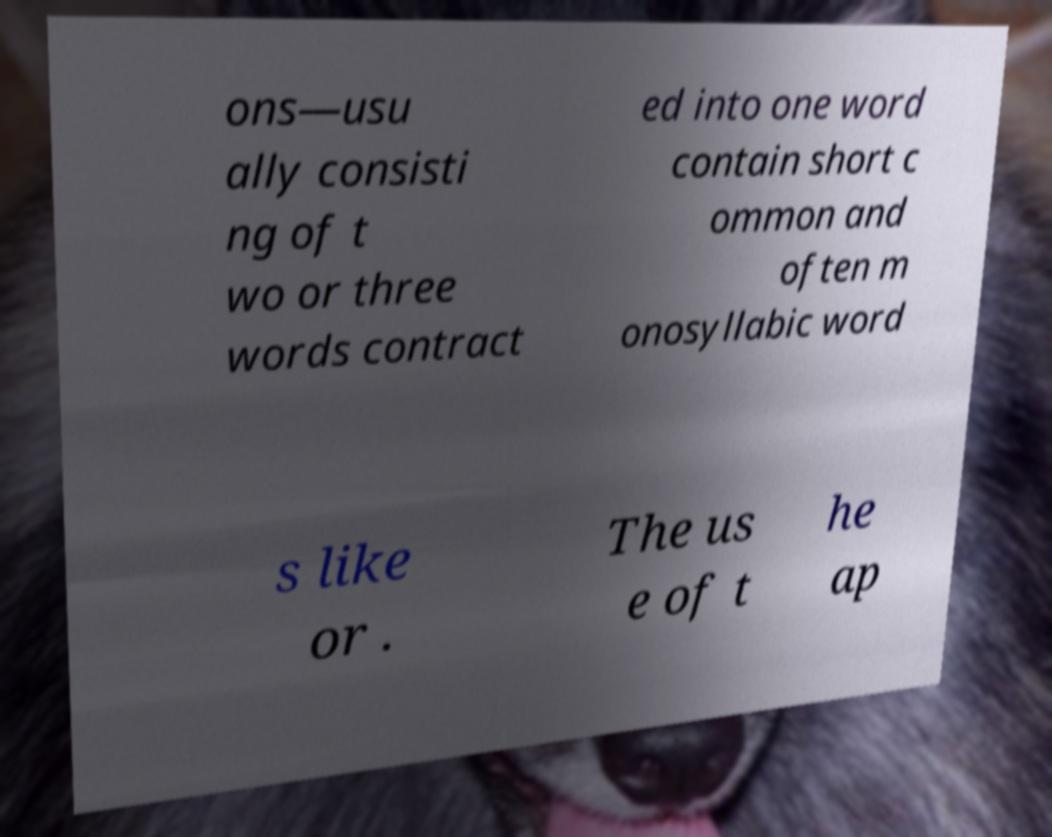What messages or text are displayed in this image? I need them in a readable, typed format. ons—usu ally consisti ng of t wo or three words contract ed into one word contain short c ommon and often m onosyllabic word s like or . The us e of t he ap 